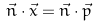<formula> <loc_0><loc_0><loc_500><loc_500>\vec { n } \cdot \vec { x } = \vec { n } \cdot \vec { p }</formula> 